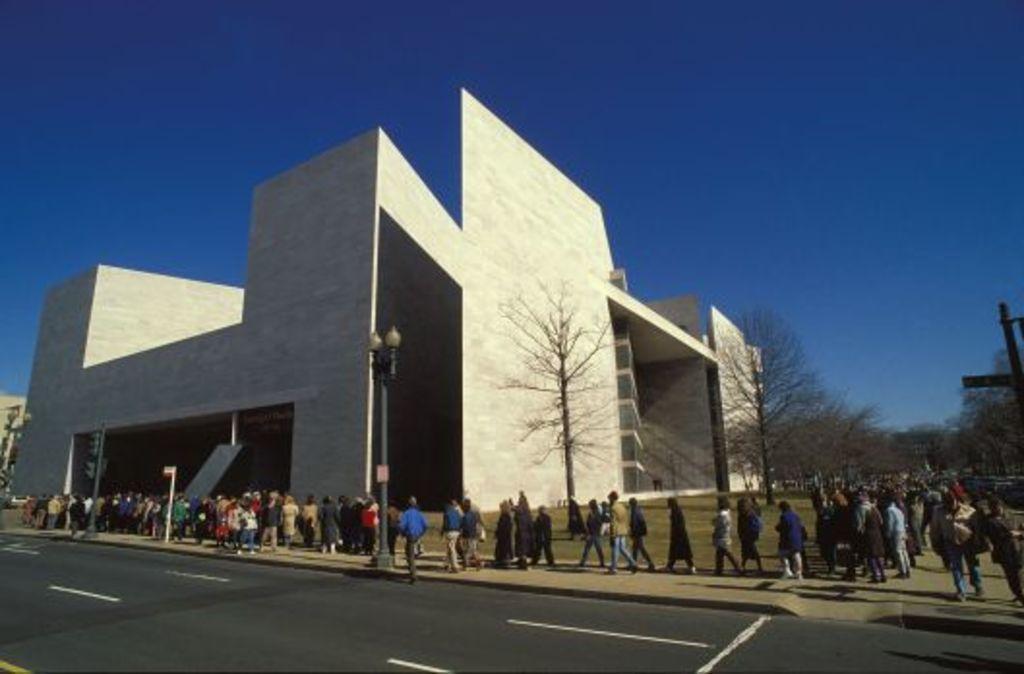Please provide a concise description of this image. In the background of the image there is a building. There are trees. There are people walking on the footpath. At the bottom of the image there is road. At the top of the image there is sky. 